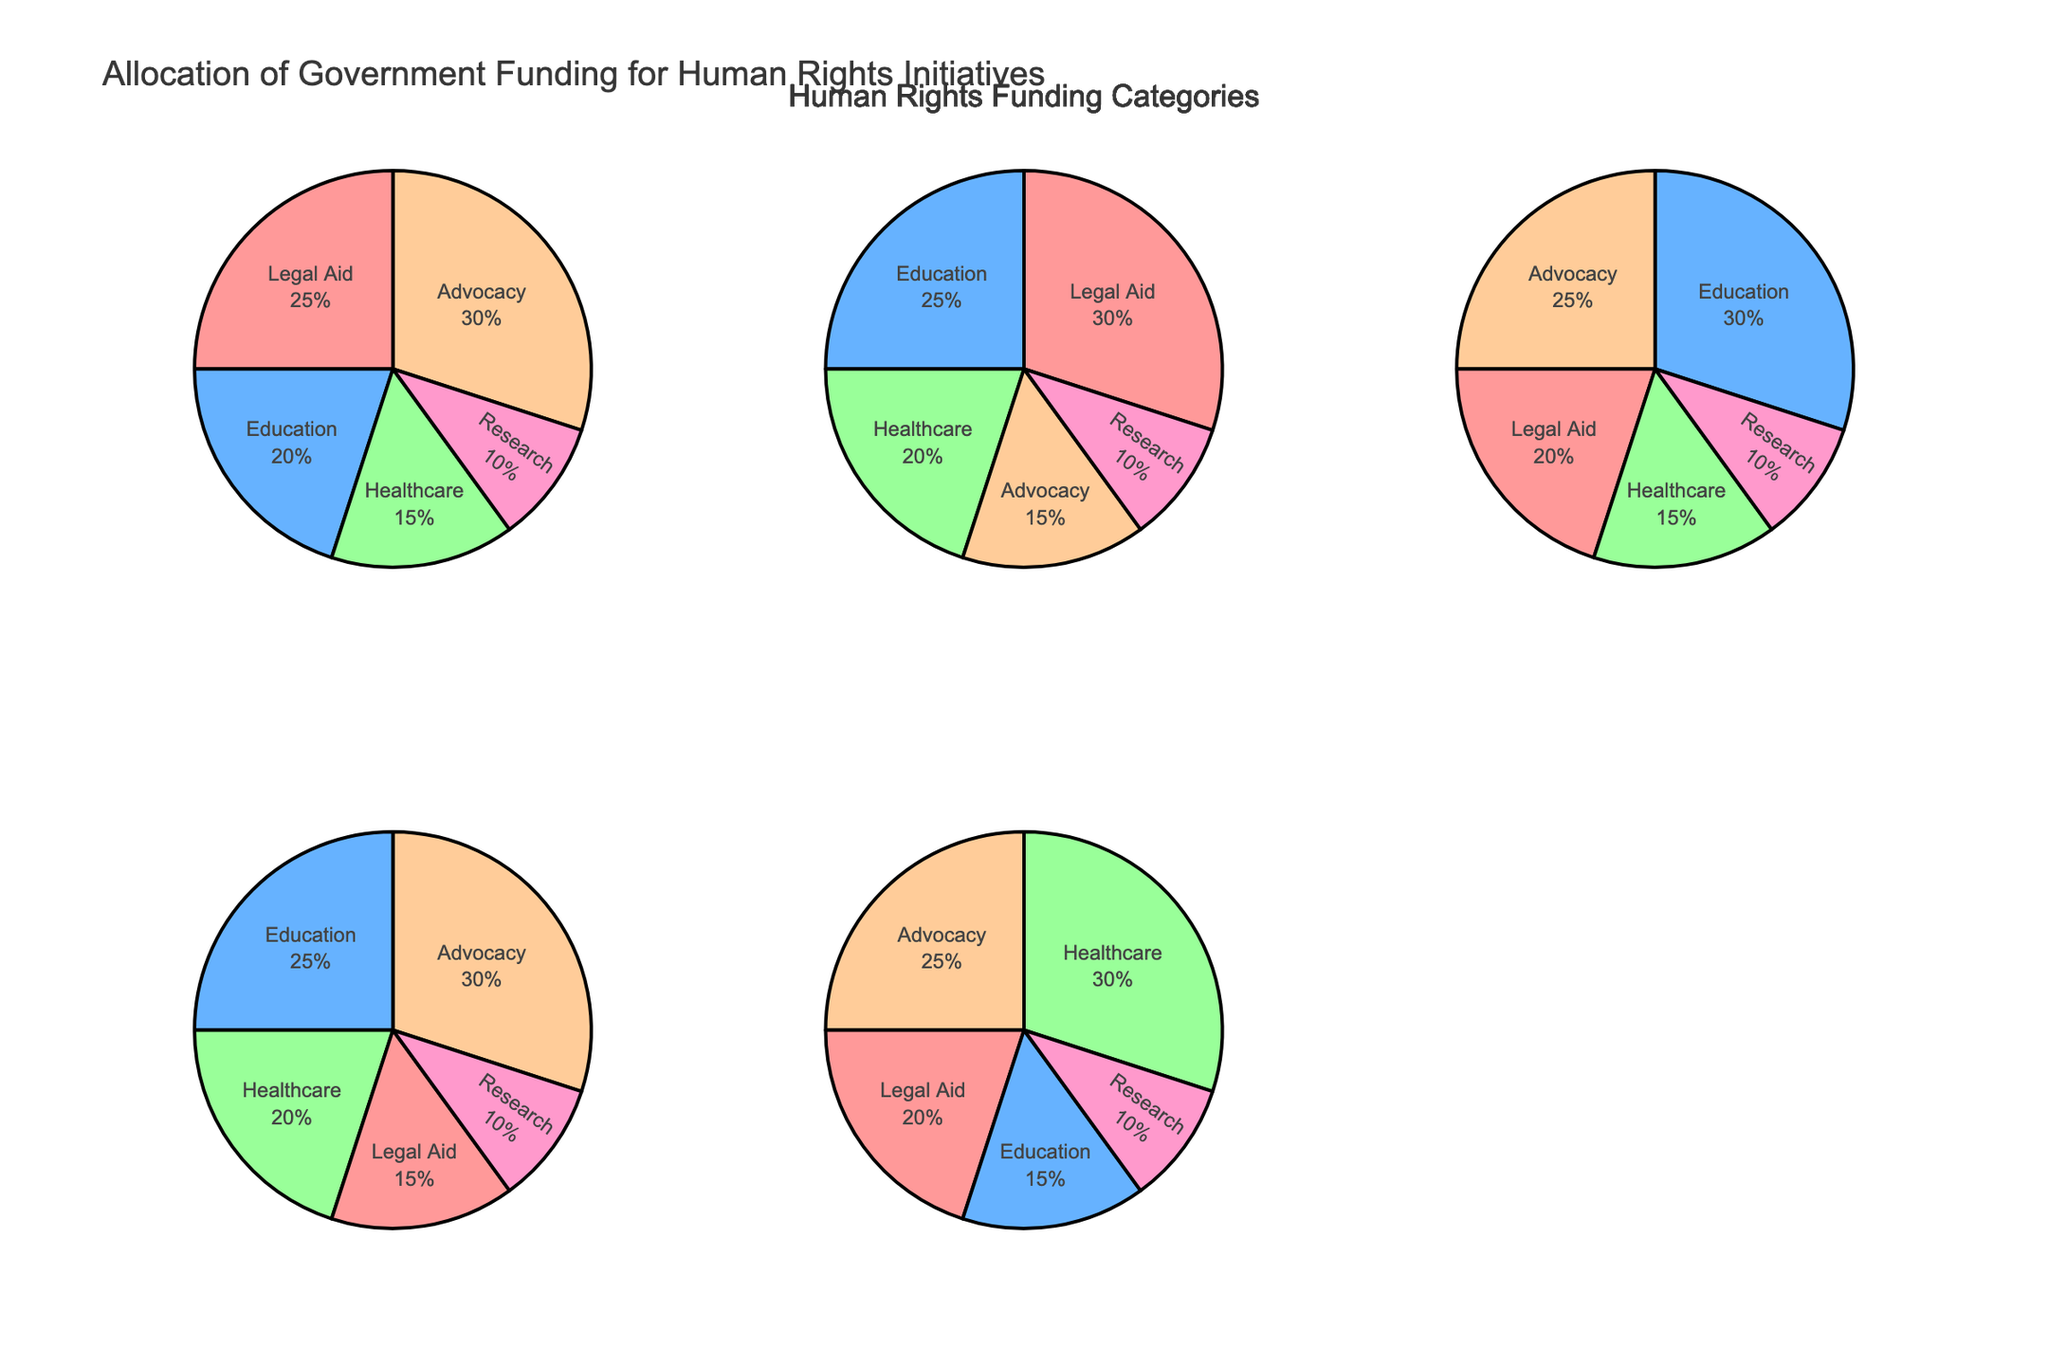What is the title of the overall figure? The title is displayed at the top of the figure. It reads "Historical Czech Football Club Success Rates by Decade".
Answer: Historical Czech Football Club Success Rates by Decade Which club had the highest success rate in the 1930s? Looking at the subplot for the 1930s, the club with the highest success rate is Sparta Prague with 80%.
Answer: Sparta Prague How many trophies did Slavia Prague win in the 1940s? In the 1940s subplot, the size of the bubble for Slavia Prague indicates they won 5 trophies.
Answer: 5 Which decade had the most clubs represented on the plot? By counting the number of bubbles in each subplot, the 1950s had 3 clubs represented (Dukla Prague, Sparta Prague, and Slovan Liberec), the highest among all decades.
Answer: 1950s What is the combined success rate of Sparta Prague across all decades? Adding Sparta Prague's success rates from each decade: 75% (1920s) + 80% (1930s) + 60% (1940s) + 65% (1950s) + 70% (1960s) = 350%
Answer: 350% Compare Sparta Prague and Slavia Prague in the 1920s: which club had more trophies, and by how many? In the 1920s, Sparta Prague won 8 trophies and Slavia Prague won 6 trophies. The difference is 8 - 6 = 2.
Answer: Sparta Prague, by 2 Which club had a declining trend in success rate across the decades? By observing the success rates of each club in different subplots, Slavia Prague had a declining trend from 70% (1920s) to 65% (1940s) and then 60% (1960s).
Answer: Slavia Prague Was there any club continually represented in every decade shown? By checking each subplot, only Sparta Prague has a bubble in every decade (1920s, 1930s, 1940s, 1950s, 1960s).
Answer: Sparta Prague 